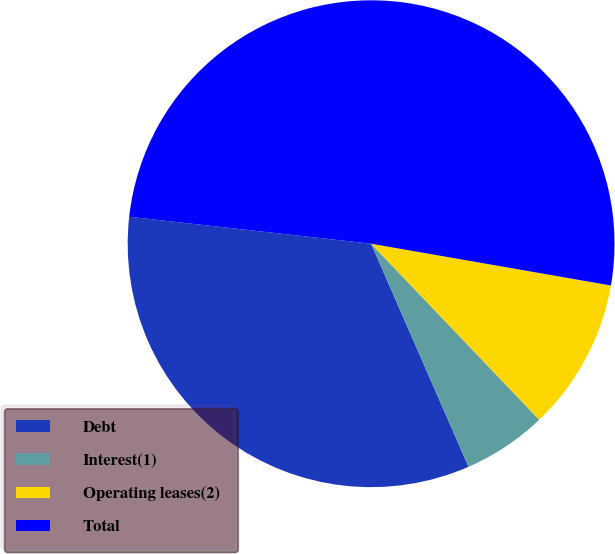Convert chart to OTSL. <chart><loc_0><loc_0><loc_500><loc_500><pie_chart><fcel>Debt<fcel>Interest(1)<fcel>Operating leases(2)<fcel>Total<nl><fcel>33.32%<fcel>5.58%<fcel>10.12%<fcel>50.98%<nl></chart> 